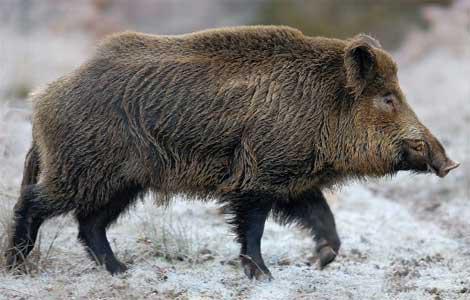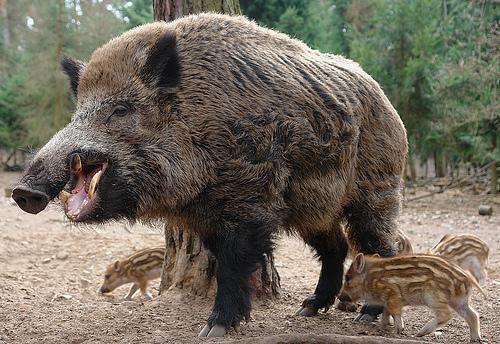The first image is the image on the left, the second image is the image on the right. Assess this claim about the two images: "There are at least two animals in one of the images.". Correct or not? Answer yes or no. Yes. 